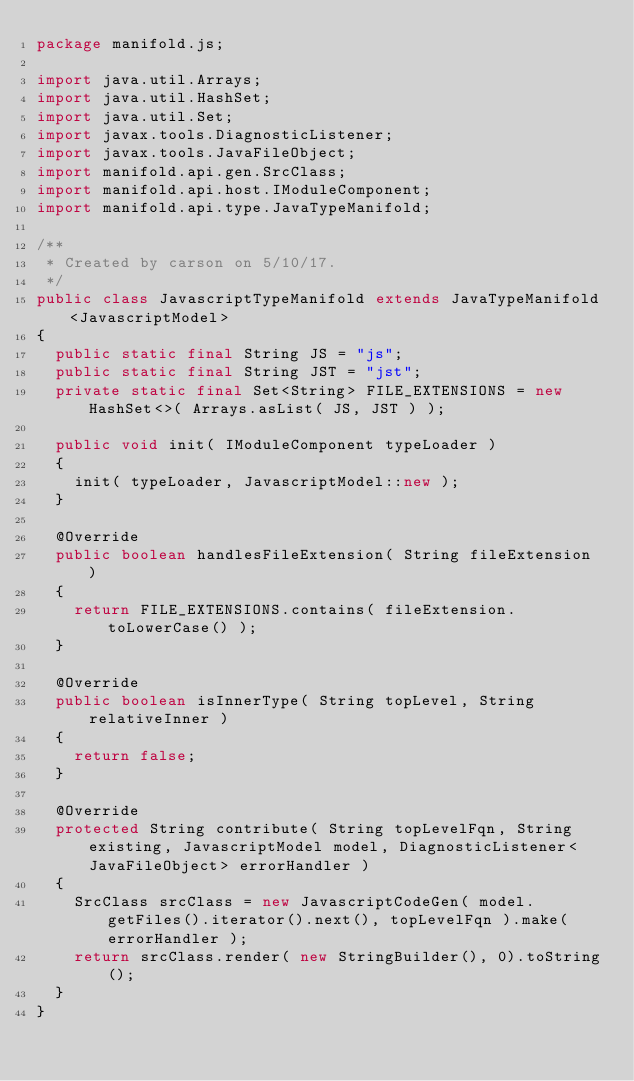<code> <loc_0><loc_0><loc_500><loc_500><_Java_>package manifold.js;

import java.util.Arrays;
import java.util.HashSet;
import java.util.Set;
import javax.tools.DiagnosticListener;
import javax.tools.JavaFileObject;
import manifold.api.gen.SrcClass;
import manifold.api.host.IModuleComponent;
import manifold.api.type.JavaTypeManifold;

/**
 * Created by carson on 5/10/17.
 */
public class JavascriptTypeManifold extends JavaTypeManifold<JavascriptModel>
{
  public static final String JS = "js";
  public static final String JST = "jst";
  private static final Set<String> FILE_EXTENSIONS = new HashSet<>( Arrays.asList( JS, JST ) );

  public void init( IModuleComponent typeLoader )
  {
    init( typeLoader, JavascriptModel::new );
  }

  @Override
  public boolean handlesFileExtension( String fileExtension )
  {
    return FILE_EXTENSIONS.contains( fileExtension.toLowerCase() );
  }

  @Override
  public boolean isInnerType( String topLevel, String relativeInner )
  {
    return false;
  }

  @Override
  protected String contribute( String topLevelFqn, String existing, JavascriptModel model, DiagnosticListener<JavaFileObject> errorHandler )
  {
    SrcClass srcClass = new JavascriptCodeGen( model.getFiles().iterator().next(), topLevelFqn ).make( errorHandler );
    return srcClass.render( new StringBuilder(), 0).toString();
  }
}</code> 